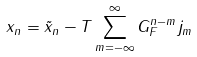<formula> <loc_0><loc_0><loc_500><loc_500>x _ { n } = \tilde { x } _ { n } - T \sum _ { m = - \infty } ^ { \infty } G _ { F } ^ { n - m } j _ { m }</formula> 